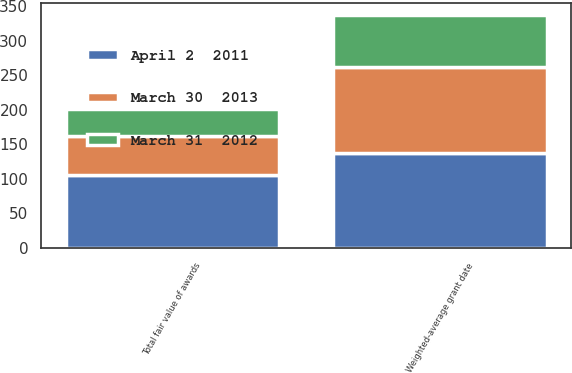Convert chart. <chart><loc_0><loc_0><loc_500><loc_500><stacked_bar_chart><ecel><fcel>Weighted-average grant date<fcel>Total fair value of awards<nl><fcel>April 2  2011<fcel>137.45<fcel>106.2<nl><fcel>March 30  2013<fcel>124.43<fcel>56.3<nl><fcel>March 31  2012<fcel>75.29<fcel>39<nl></chart> 